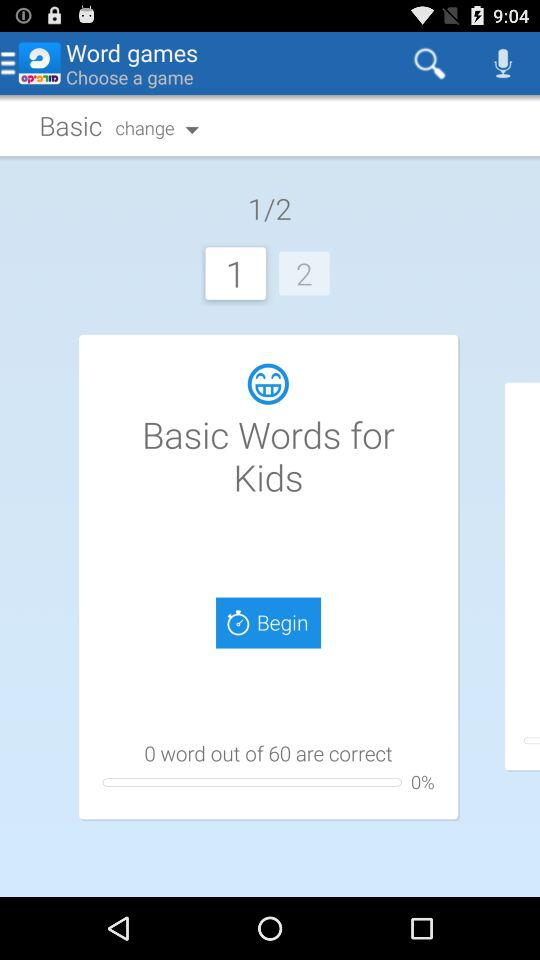What is the total number of words? The total number of words is 60. 